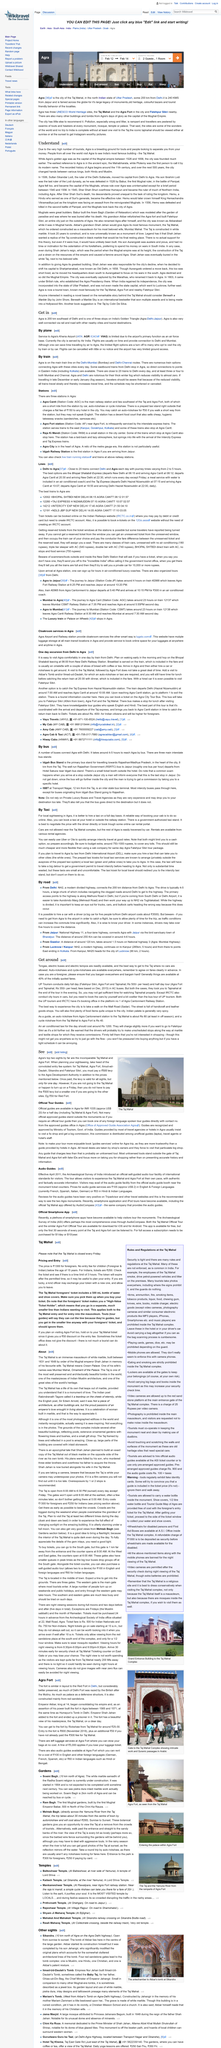Draw attention to some important aspects in this diagram. The Taj Mahal and Agra Fort are the top two sights in Agra, renowned for their architectural beauty and historical significance. Agra's Kheria airport serves as a primary function as an Air Force base, which is its primary role and main function, it is the main place where air force activities take place and it primarily serves the air force rather than commercial or civilian aviation. Agra has a total of three UNESCO World Heritage sites. The image features a building known as the Taj Mahal, which is a well-known landmark in India. There are four sandstone gates that lead to the complex housing the tomb of Akbar, a Mughal emperor. 